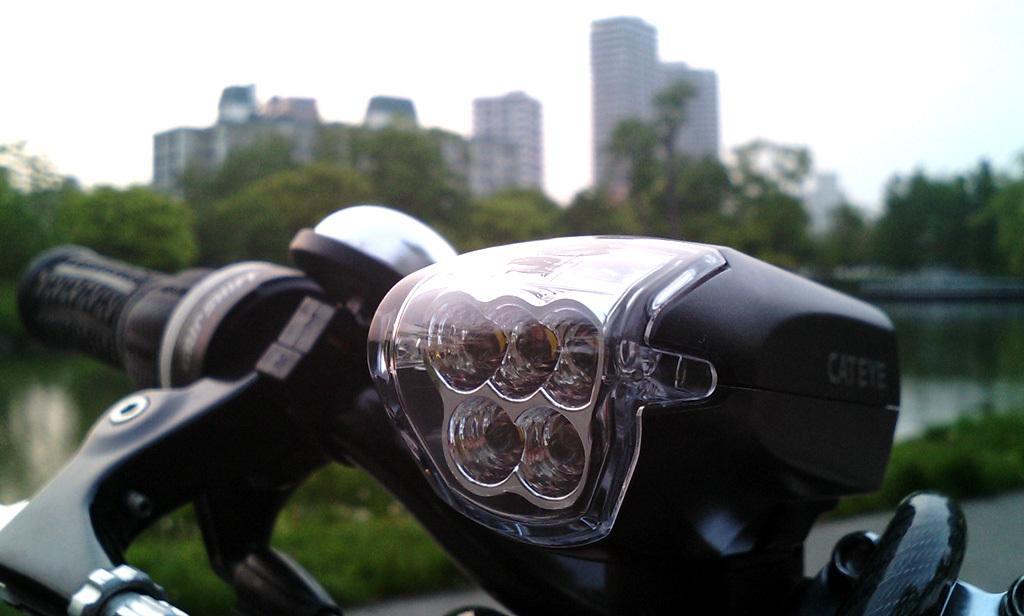Can you describe this image briefly? In this image we can see one of the parts of the motorcycle. And behind this we can see trees, buildings, and lake. And clouds in the sky. 